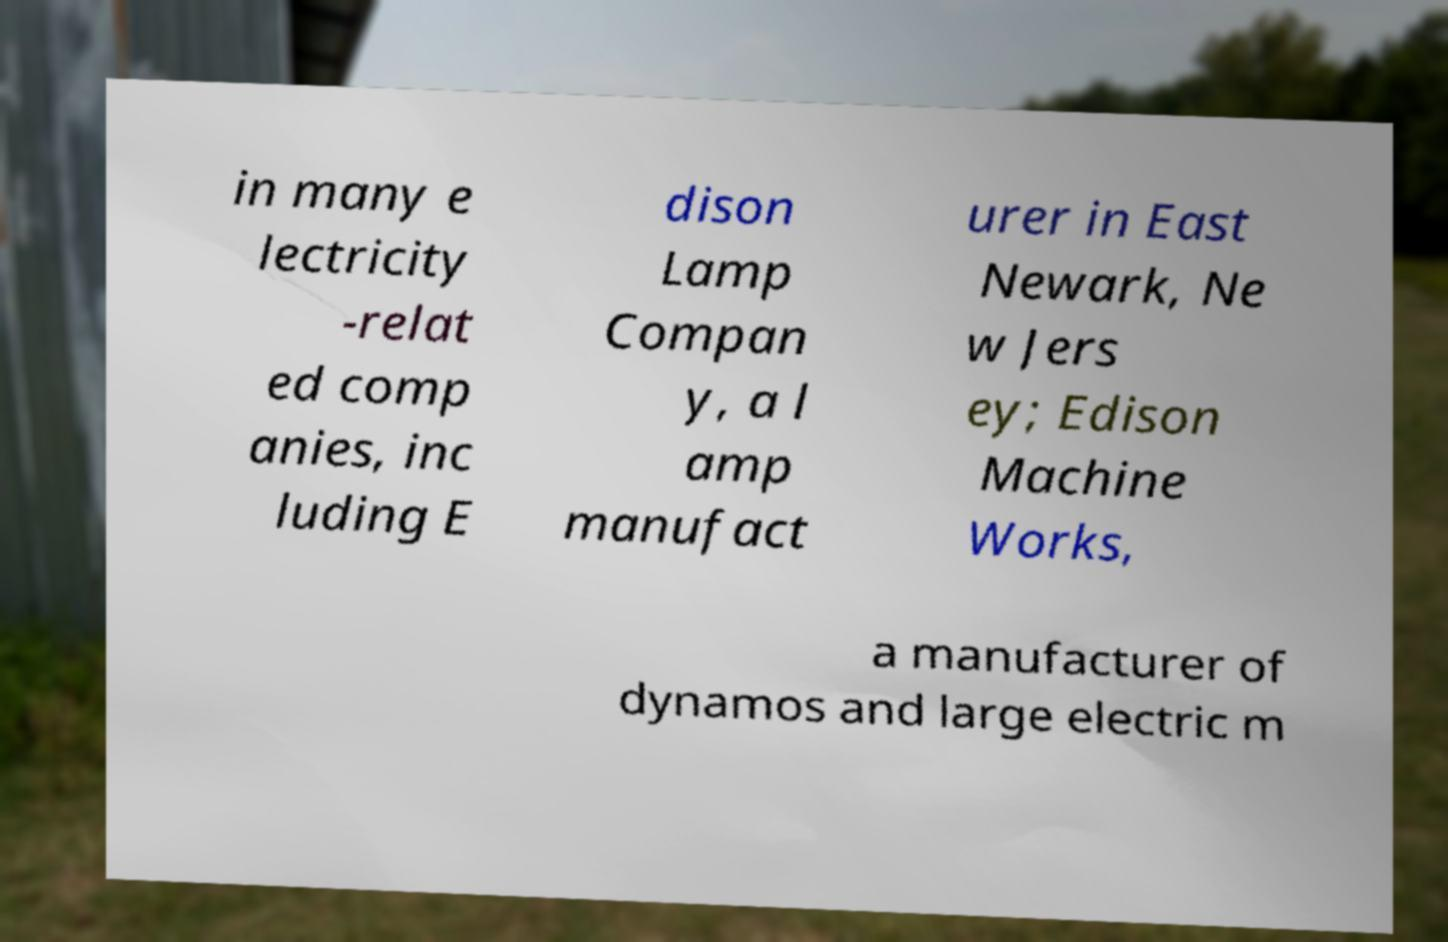For documentation purposes, I need the text within this image transcribed. Could you provide that? in many e lectricity -relat ed comp anies, inc luding E dison Lamp Compan y, a l amp manufact urer in East Newark, Ne w Jers ey; Edison Machine Works, a manufacturer of dynamos and large electric m 